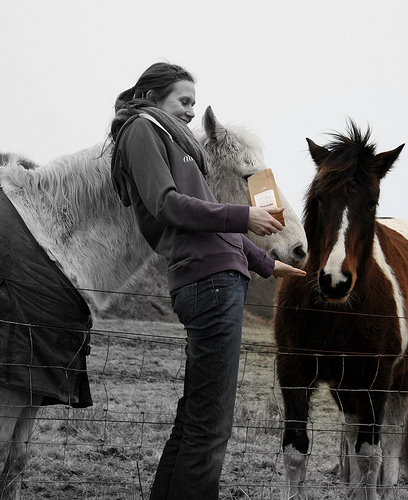<image>
Can you confirm if the brown horse is behind the girl? Yes. From this viewpoint, the brown horse is positioned behind the girl, with the girl partially or fully occluding the brown horse. Is the white horse behind the women? Yes. From this viewpoint, the white horse is positioned behind the women, with the women partially or fully occluding the white horse. 